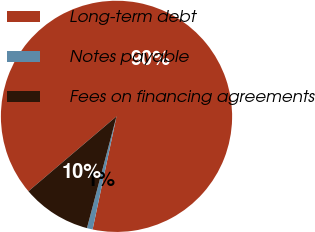Convert chart. <chart><loc_0><loc_0><loc_500><loc_500><pie_chart><fcel>Long-term debt<fcel>Notes payable<fcel>Fees on financing agreements<nl><fcel>89.52%<fcel>0.8%<fcel>9.67%<nl></chart> 